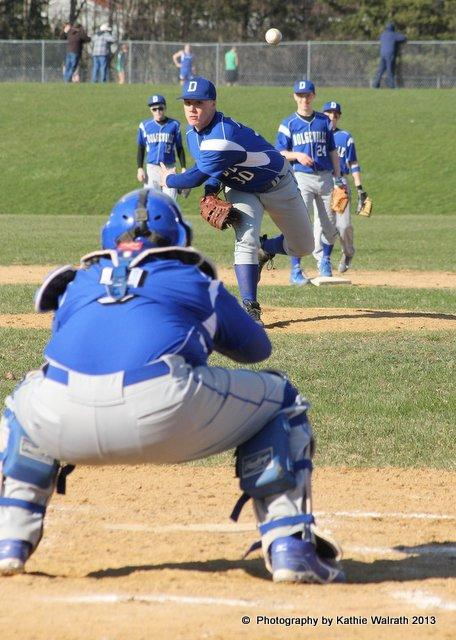What numbered player last touched the ball?

Choices:
A) one
B) 30
C) 13
D) two 30 